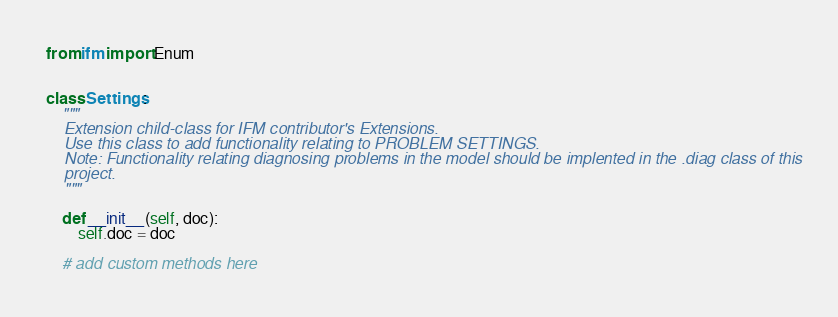Convert code to text. <code><loc_0><loc_0><loc_500><loc_500><_Python_>from ifm import Enum


class Settings:
    """
    Extension child-class for IFM contributor's Extensions.
    Use this class to add functionality relating to PROBLEM SETTINGS.
    Note: Functionality relating diagnosing problems in the model should be implented in the .diag class of this
    project.
    """

    def __init__(self, doc):
        self.doc = doc

    # add custom methods here
</code> 